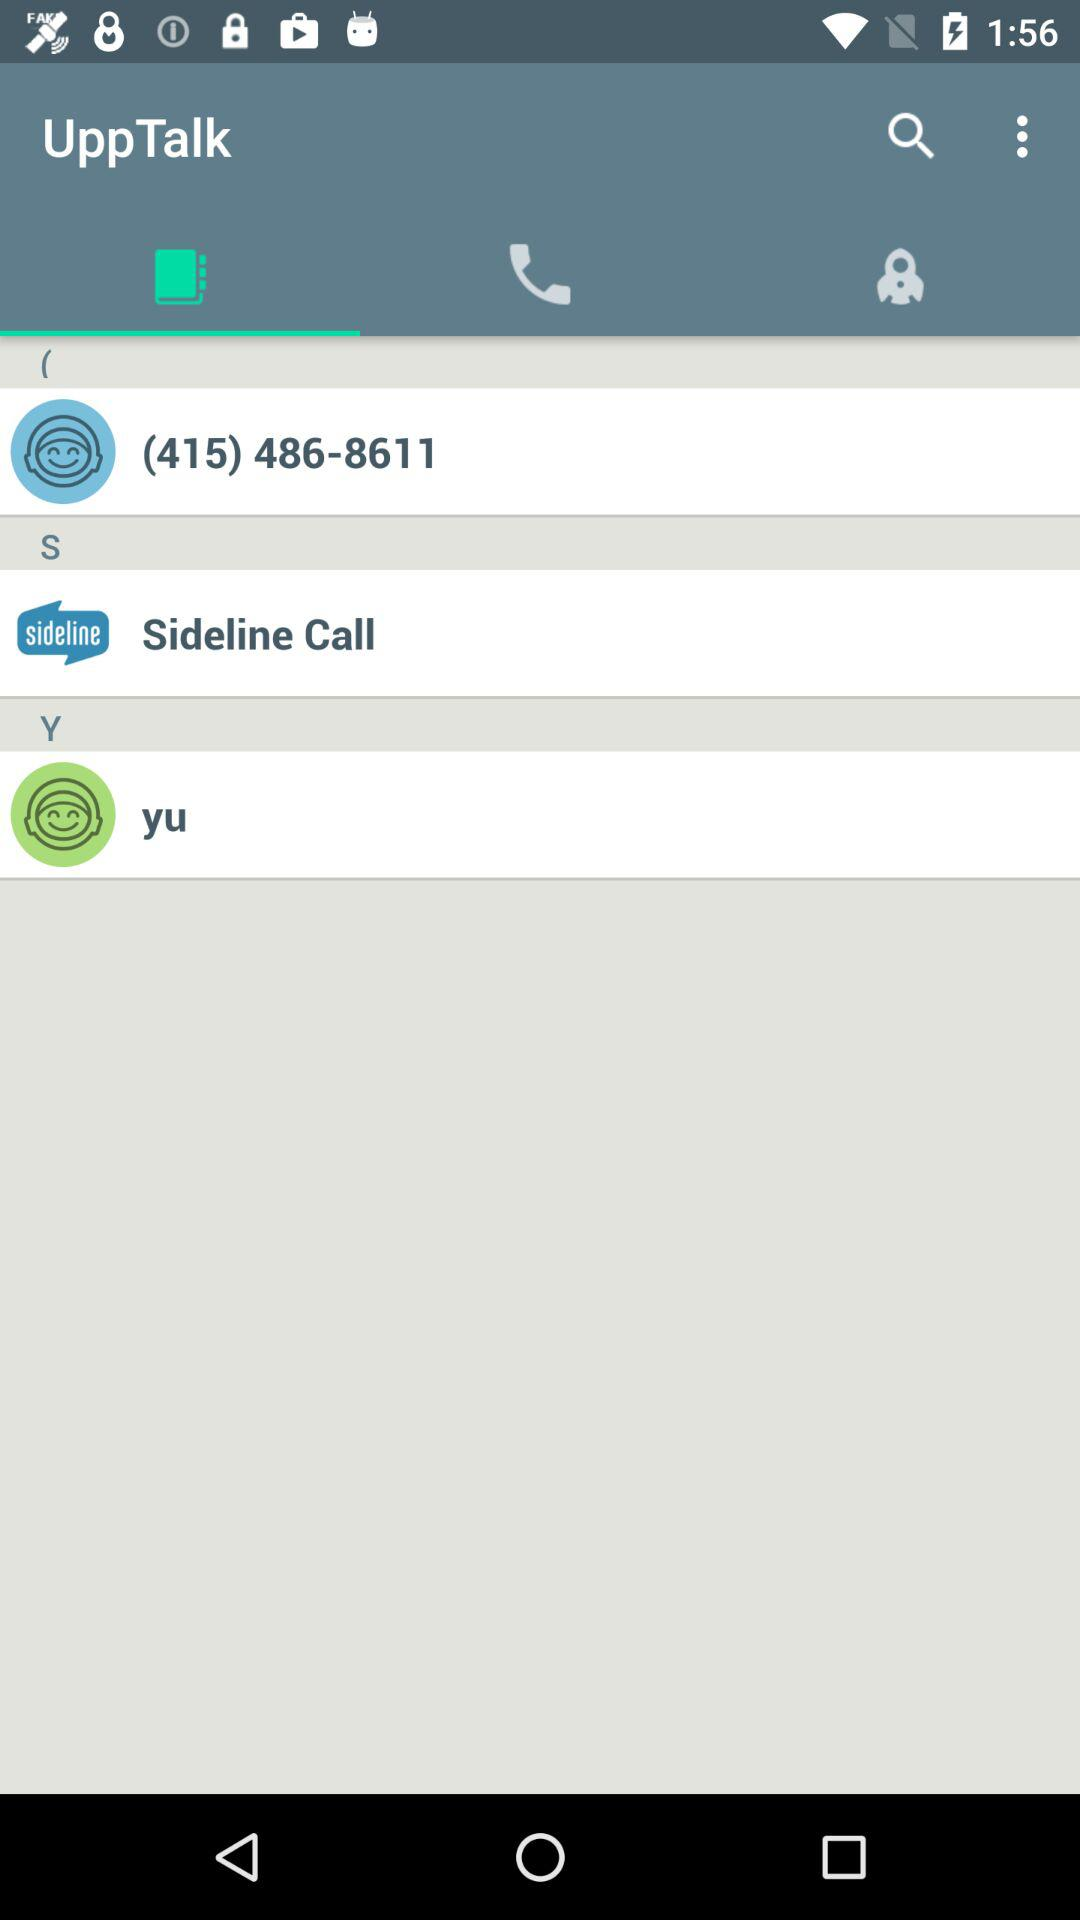What is the name of the application? The name of the application is "UppTalk". 